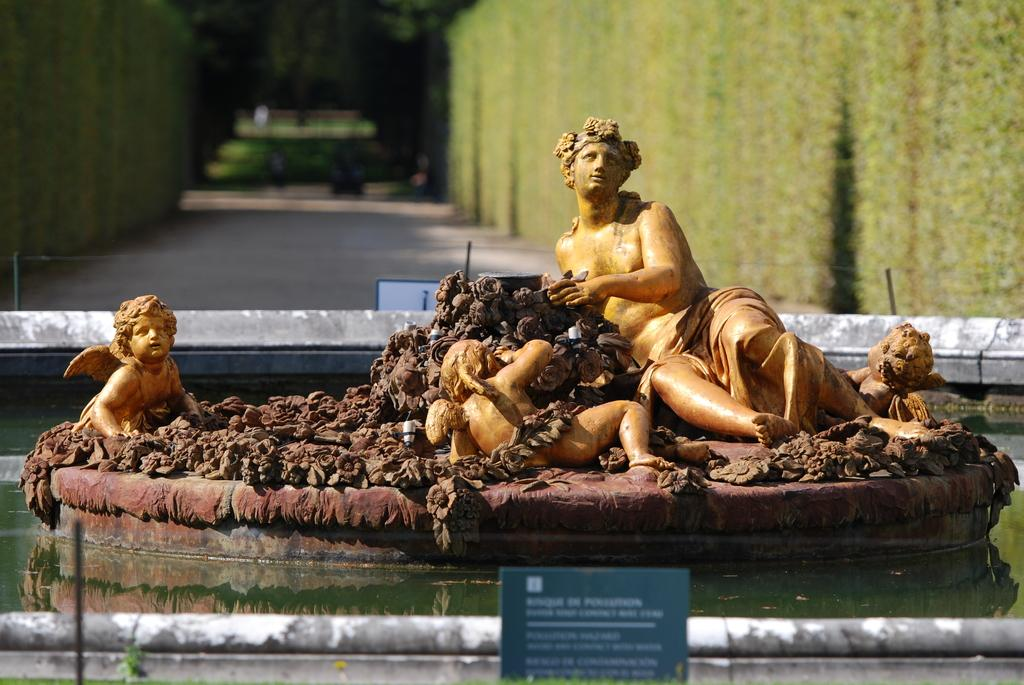What can be seen running through the image? There is a path in the image. What is located along the path? There are statues on the path. What natural element is visible in the image? There is water visible in the image. What type of signage is present in the image? There is a board with writing in the image. What type of copper material is used to create the statues in the image? There is no mention of copper or any specific material used to create the statues in the image. 